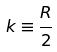Convert formula to latex. <formula><loc_0><loc_0><loc_500><loc_500>k \equiv \frac { R } { 2 }</formula> 